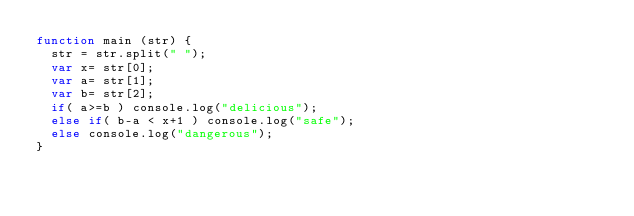Convert code to text. <code><loc_0><loc_0><loc_500><loc_500><_JavaScript_>function main (str) {
  str = str.split(" ");
  var x= str[0];
  var a= str[1];
  var b= str[2];
  if( a>=b ) console.log("delicious");
  else if( b-a < x+1 ) console.log("safe");
  else console.log("dangerous");
}</code> 